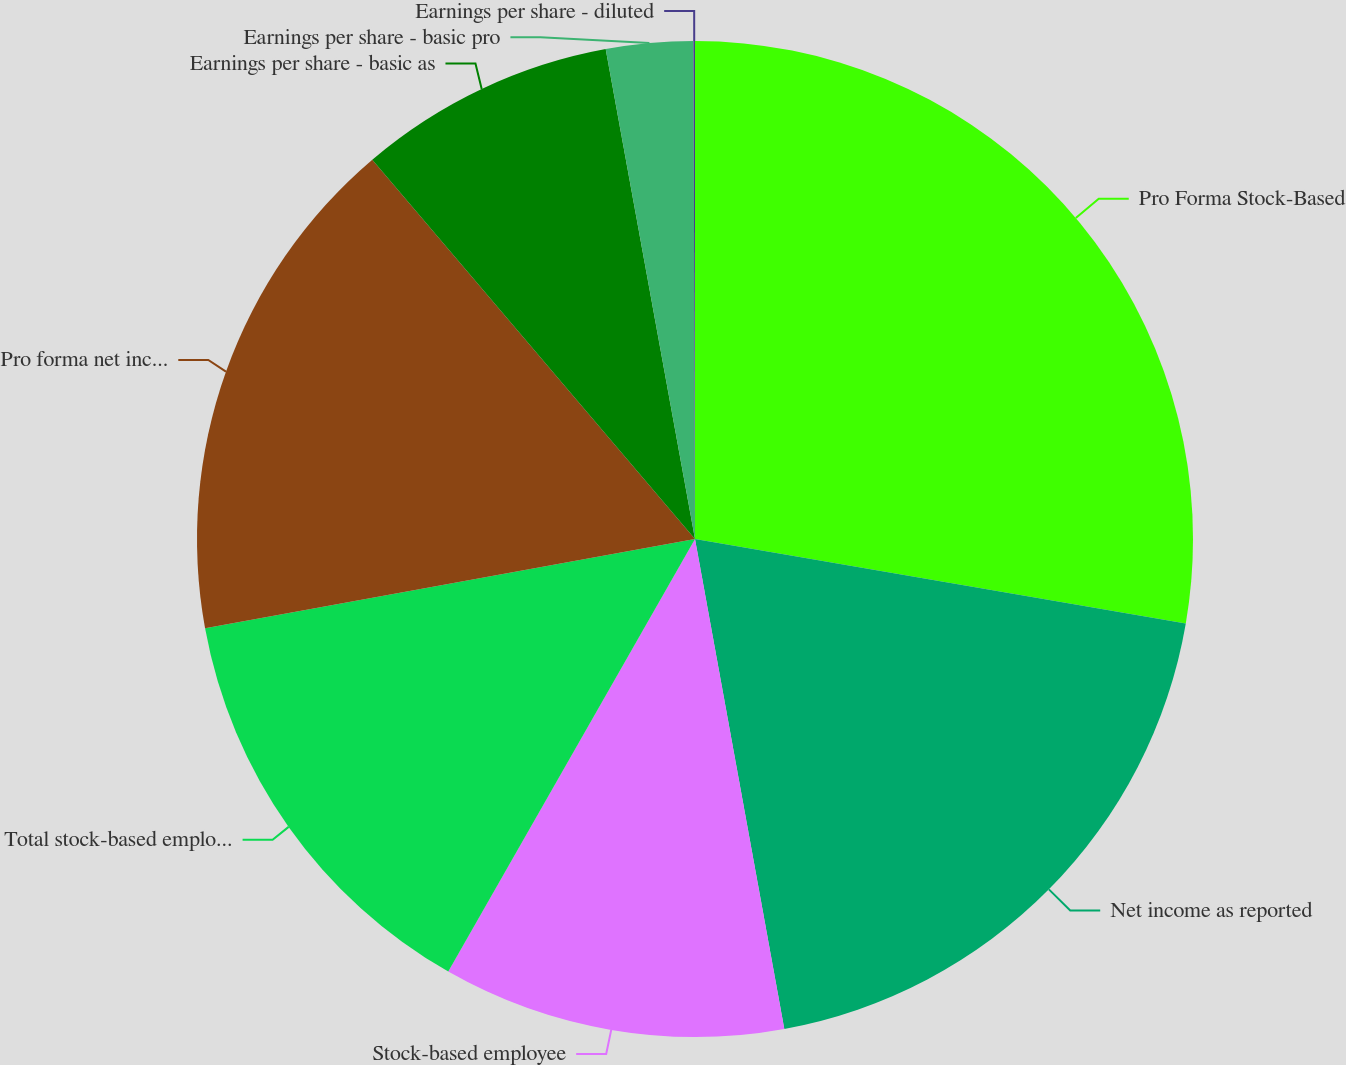<chart> <loc_0><loc_0><loc_500><loc_500><pie_chart><fcel>Pro Forma Stock-Based<fcel>Net income as reported<fcel>Stock-based employee<fcel>Total stock-based employee<fcel>Pro forma net income<fcel>Earnings per share - basic as<fcel>Earnings per share - basic pro<fcel>Earnings per share - diluted<nl><fcel>27.71%<fcel>19.42%<fcel>11.12%<fcel>13.88%<fcel>16.65%<fcel>8.35%<fcel>2.82%<fcel>0.05%<nl></chart> 